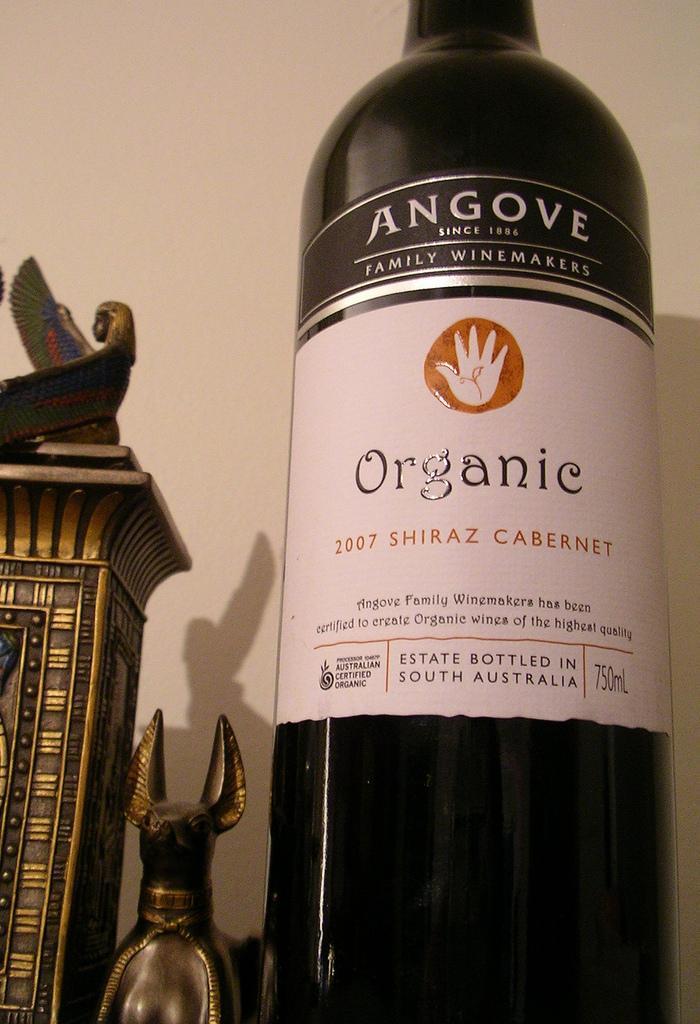Describe this image in one or two sentences. There is a bottle on the right side of this image. We can see some objects on the left side of this image and the wall is in the background. 